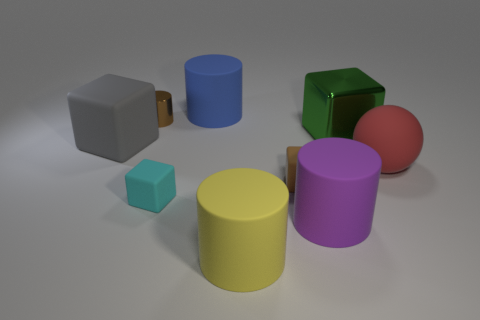Is there any other thing that is the same shape as the red object?
Make the answer very short. No. There is a cyan matte thing; does it have the same shape as the big matte object that is in front of the purple matte cylinder?
Offer a terse response. No. Is the size of the brown matte cube that is on the left side of the big red ball the same as the cylinder that is to the left of the cyan object?
Your answer should be compact. Yes. There is a big cylinder that is behind the tiny matte cube that is on the right side of the cyan thing; are there any small cylinders right of it?
Ensure brevity in your answer.  No. Are there fewer purple objects in front of the big rubber ball than purple cylinders that are on the right side of the green object?
Offer a very short reply. No. The big yellow thing that is the same material as the purple cylinder is what shape?
Ensure brevity in your answer.  Cylinder. There is a object that is on the left side of the tiny brown thing behind the big thing left of the blue matte object; what is its size?
Make the answer very short. Large. Are there more small shiny cylinders than cyan matte balls?
Keep it short and to the point. Yes. Is the color of the block that is behind the large gray matte block the same as the large thing that is to the right of the shiny cube?
Give a very brief answer. No. Do the large thing that is in front of the big purple rubber cylinder and the large cylinder right of the yellow matte cylinder have the same material?
Make the answer very short. Yes. 